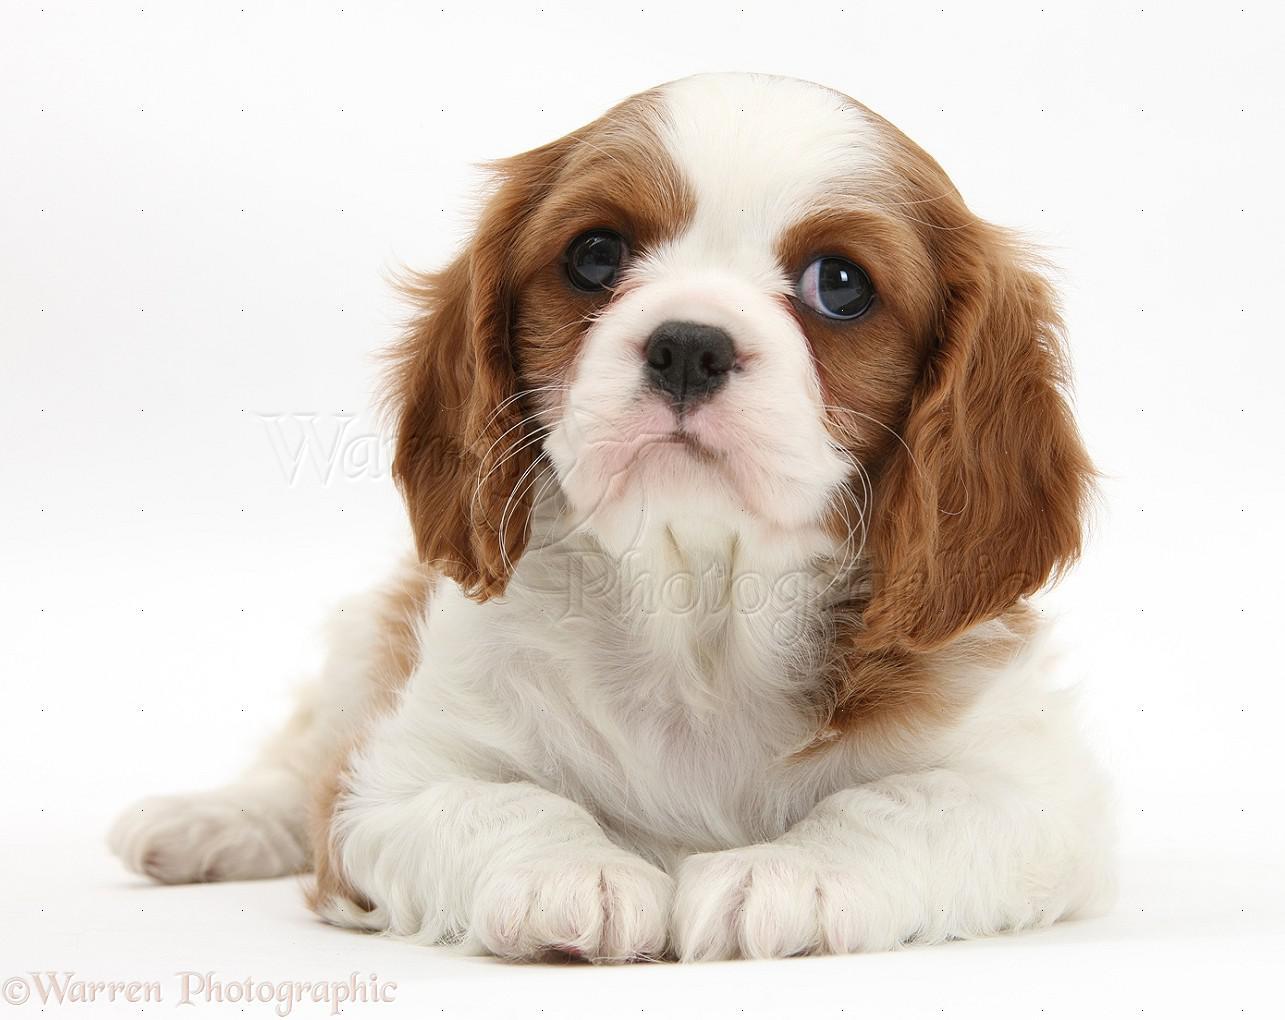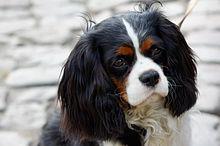The first image is the image on the left, the second image is the image on the right. For the images displayed, is the sentence "In one of the images, the puppy is lying down with its chin resting on something" factually correct? Answer yes or no. No. 